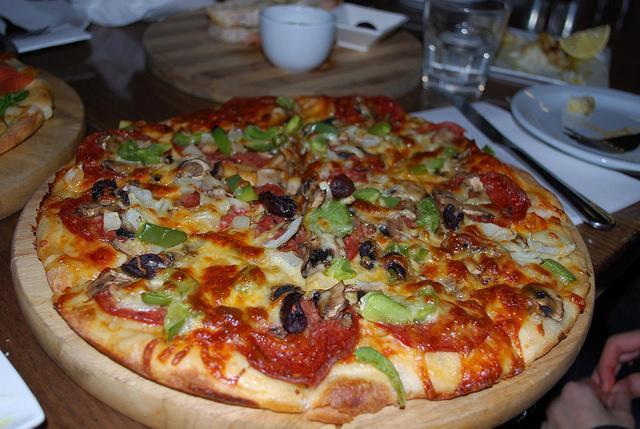How many pizzas are there?
Give a very brief answer. 2. How many cups are in the photo?
Give a very brief answer. 2. 